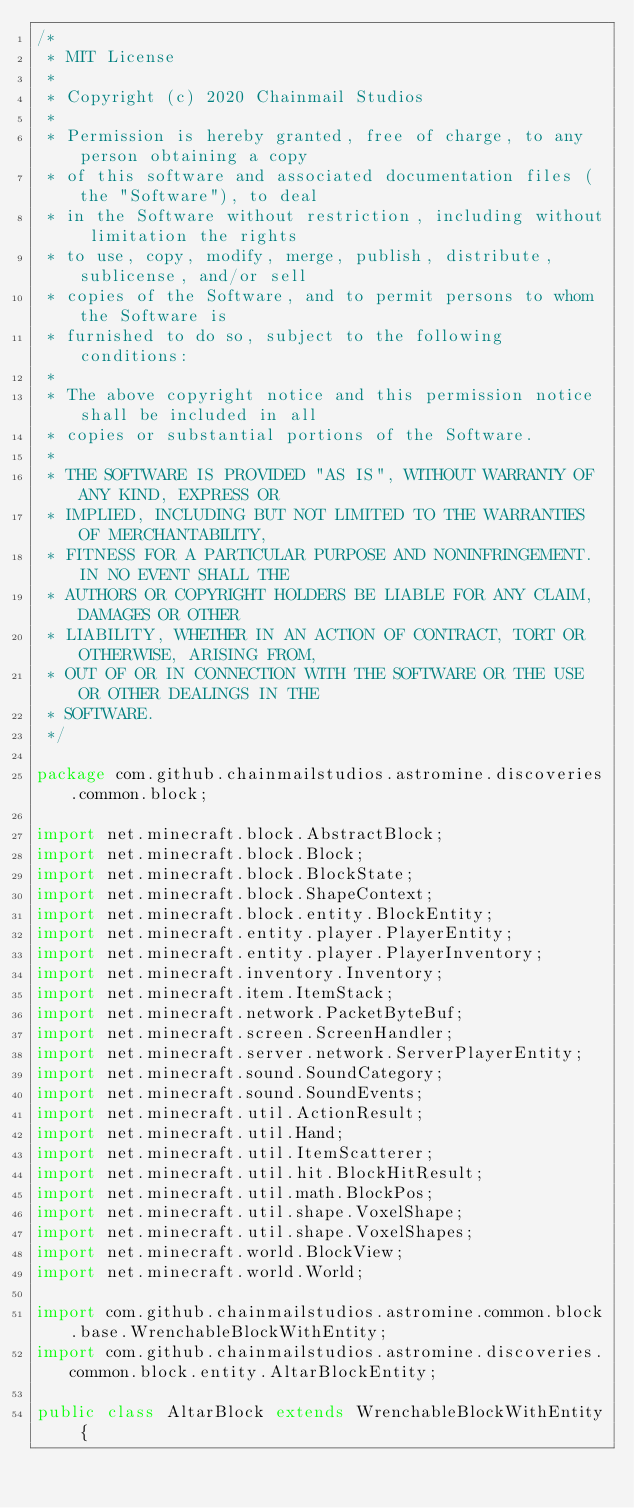Convert code to text. <code><loc_0><loc_0><loc_500><loc_500><_Java_>/*
 * MIT License
 *
 * Copyright (c) 2020 Chainmail Studios
 *
 * Permission is hereby granted, free of charge, to any person obtaining a copy
 * of this software and associated documentation files (the "Software"), to deal
 * in the Software without restriction, including without limitation the rights
 * to use, copy, modify, merge, publish, distribute, sublicense, and/or sell
 * copies of the Software, and to permit persons to whom the Software is
 * furnished to do so, subject to the following conditions:
 *
 * The above copyright notice and this permission notice shall be included in all
 * copies or substantial portions of the Software.
 *
 * THE SOFTWARE IS PROVIDED "AS IS", WITHOUT WARRANTY OF ANY KIND, EXPRESS OR
 * IMPLIED, INCLUDING BUT NOT LIMITED TO THE WARRANTIES OF MERCHANTABILITY,
 * FITNESS FOR A PARTICULAR PURPOSE AND NONINFRINGEMENT. IN NO EVENT SHALL THE
 * AUTHORS OR COPYRIGHT HOLDERS BE LIABLE FOR ANY CLAIM, DAMAGES OR OTHER
 * LIABILITY, WHETHER IN AN ACTION OF CONTRACT, TORT OR OTHERWISE, ARISING FROM,
 * OUT OF OR IN CONNECTION WITH THE SOFTWARE OR THE USE OR OTHER DEALINGS IN THE
 * SOFTWARE.
 */

package com.github.chainmailstudios.astromine.discoveries.common.block;

import net.minecraft.block.AbstractBlock;
import net.minecraft.block.Block;
import net.minecraft.block.BlockState;
import net.minecraft.block.ShapeContext;
import net.minecraft.block.entity.BlockEntity;
import net.minecraft.entity.player.PlayerEntity;
import net.minecraft.entity.player.PlayerInventory;
import net.minecraft.inventory.Inventory;
import net.minecraft.item.ItemStack;
import net.minecraft.network.PacketByteBuf;
import net.minecraft.screen.ScreenHandler;
import net.minecraft.server.network.ServerPlayerEntity;
import net.minecraft.sound.SoundCategory;
import net.minecraft.sound.SoundEvents;
import net.minecraft.util.ActionResult;
import net.minecraft.util.Hand;
import net.minecraft.util.ItemScatterer;
import net.minecraft.util.hit.BlockHitResult;
import net.minecraft.util.math.BlockPos;
import net.minecraft.util.shape.VoxelShape;
import net.minecraft.util.shape.VoxelShapes;
import net.minecraft.world.BlockView;
import net.minecraft.world.World;

import com.github.chainmailstudios.astromine.common.block.base.WrenchableBlockWithEntity;
import com.github.chainmailstudios.astromine.discoveries.common.block.entity.AltarBlockEntity;

public class AltarBlock extends WrenchableBlockWithEntity {</code> 